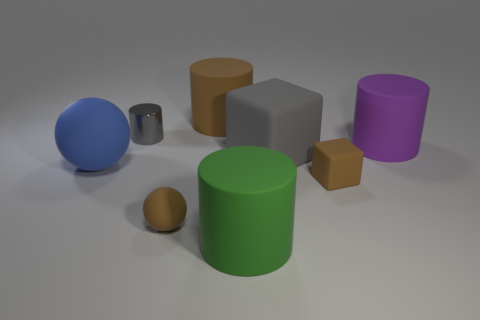Add 1 red rubber objects. How many objects exist? 9 Subtract all cubes. How many objects are left? 6 Add 1 large green metal objects. How many large green metal objects exist? 1 Subtract 1 purple cylinders. How many objects are left? 7 Subtract all brown rubber spheres. Subtract all big spheres. How many objects are left? 6 Add 6 balls. How many balls are left? 8 